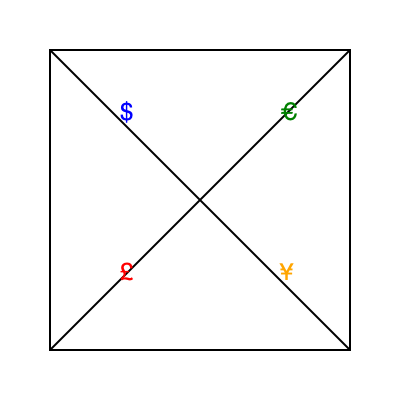If the complex origami-like shape shown above is mentally unfolded, which financial symbol would appear in the top-right corner? To solve this problem, we need to mentally unfold the origami-like shape:

1. The shape appears to be a cube-like structure with folded edges.
2. The visible face is divided into four triangular sections by diagonal folds.
3. Each section contains a different currency symbol:
   - Top-left: $ (Dollar)
   - Bottom-left: £ (Pound)
   - Bottom-right: ¥ (Yen)
   - Top-right: € (Euro)
4. If we mentally unfold the shape, the top-right section would become a full square face.
5. The symbol in this section is the € (Euro) symbol.

Therefore, when unfolded, the € (Euro) symbol would appear in the top-right corner.
Answer: € (Euro) 